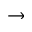Convert formula to latex. <formula><loc_0><loc_0><loc_500><loc_500>\to</formula> 